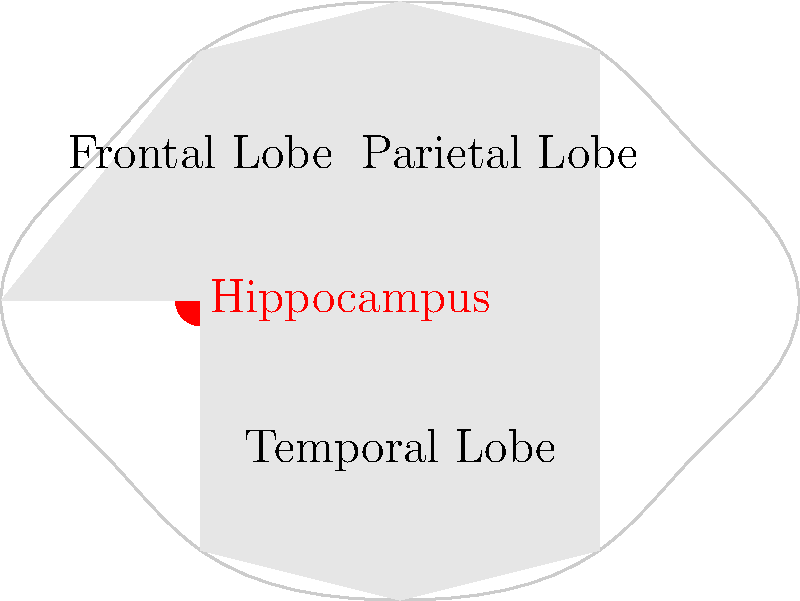In the MRI scan of a patient suspected of having Alzheimer's disease, which brain region highlighted in red is typically one of the first areas to show atrophy, and what cognitive functions are primarily associated with this region? To answer this question, let's follow these steps:

1. Identify the highlighted region: The region highlighted in red in the MRI scan is the hippocampus.

2. Understand the role of the hippocampus in Alzheimer's disease:
   a. The hippocampus is one of the first brain regions to show atrophy in Alzheimer's disease.
   b. It is part of the limbic system and plays a crucial role in memory formation and spatial navigation.

3. Cognitive functions associated with the hippocampus:
   a. Formation of new memories (especially episodic and declarative memories)
   b. Consolidation of short-term memories into long-term memories
   c. Spatial memory and navigation

4. Connection to Alzheimer's disease symptoms:
   a. Early memory loss, particularly for recent events
   b. Difficulty in forming new memories
   c. Disorientation and getting lost in familiar places

5. Importance in diagnosis:
   Hippocampal atrophy on MRI scans is a key biomarker for Alzheimer's disease, often visible before clinical symptoms become apparent.

In summary, the hippocampus is the highlighted region, and it is primarily associated with memory formation and spatial navigation. These functions are typically impaired early in the course of Alzheimer's disease.
Answer: Hippocampus; memory formation and spatial navigation 